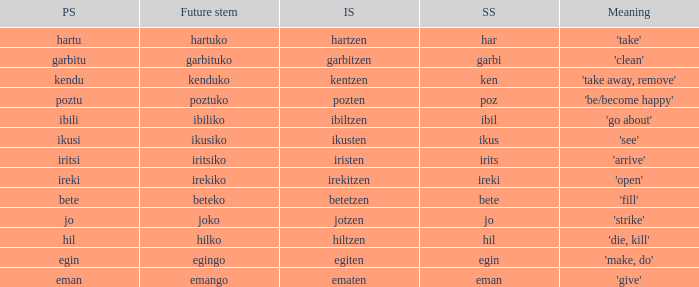What is the short stem for garbitzen? Garbi. 